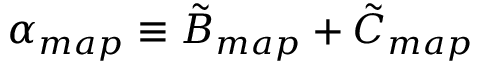<formula> <loc_0><loc_0><loc_500><loc_500>\alpha _ { m a p } \equiv \tilde { B } _ { m a p } + \tilde { C } _ { m a p }</formula> 